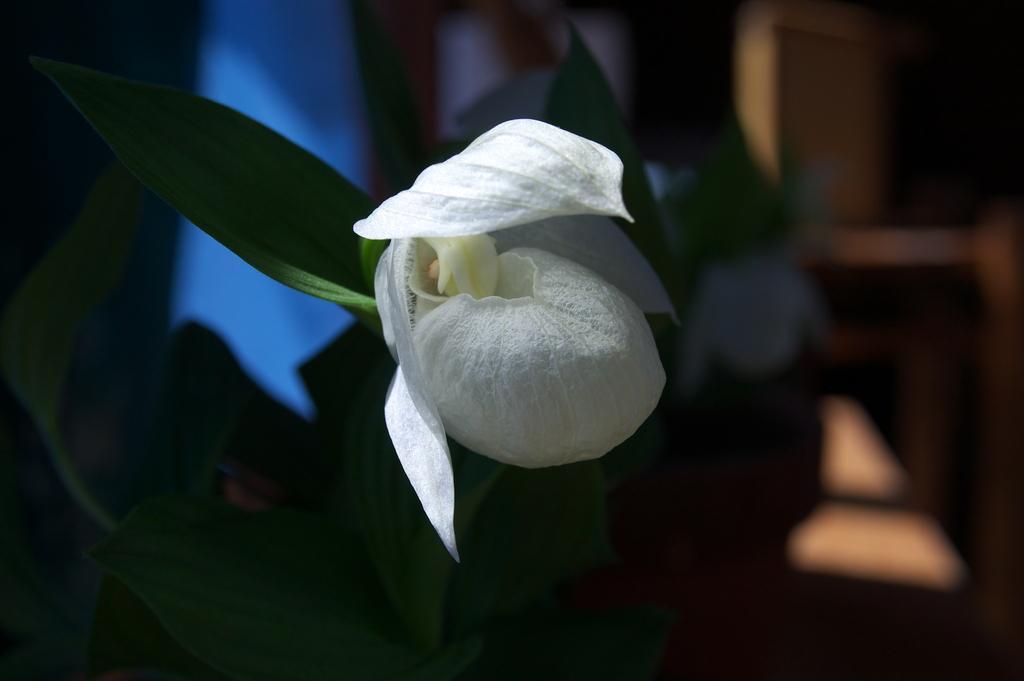What type of plant is featured in the image? There is a white flower in the image. What else can be seen in the image besides the flower? There are leaves in the image. How would you describe the background of the image? The background of the image is blurred. What type of jam is being spread on the actor's face in the image? There is no actor or jam present in the image; it features a white flower and leaves. 